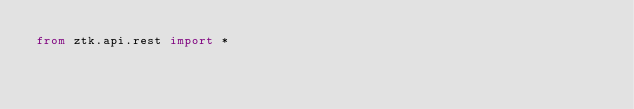Convert code to text. <code><loc_0><loc_0><loc_500><loc_500><_Python_>from ztk.api.rest import *</code> 